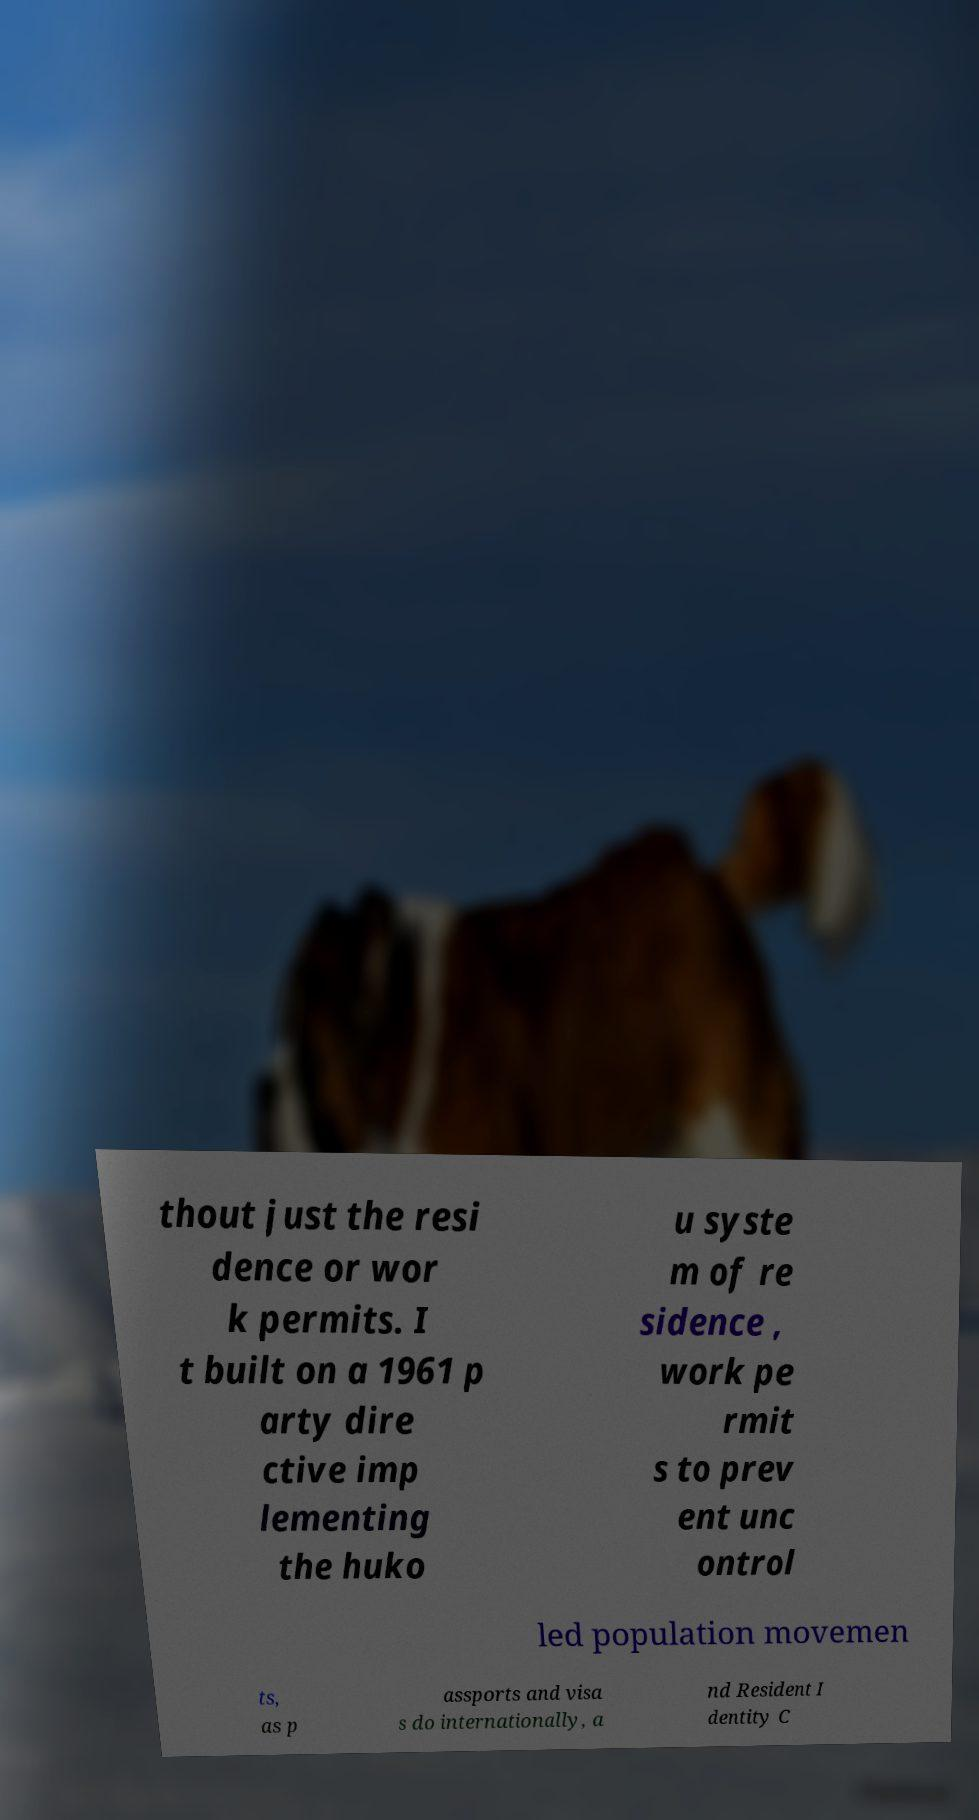What messages or text are displayed in this image? I need them in a readable, typed format. thout just the resi dence or wor k permits. I t built on a 1961 p arty dire ctive imp lementing the huko u syste m of re sidence , work pe rmit s to prev ent unc ontrol led population movemen ts, as p assports and visa s do internationally, a nd Resident I dentity C 